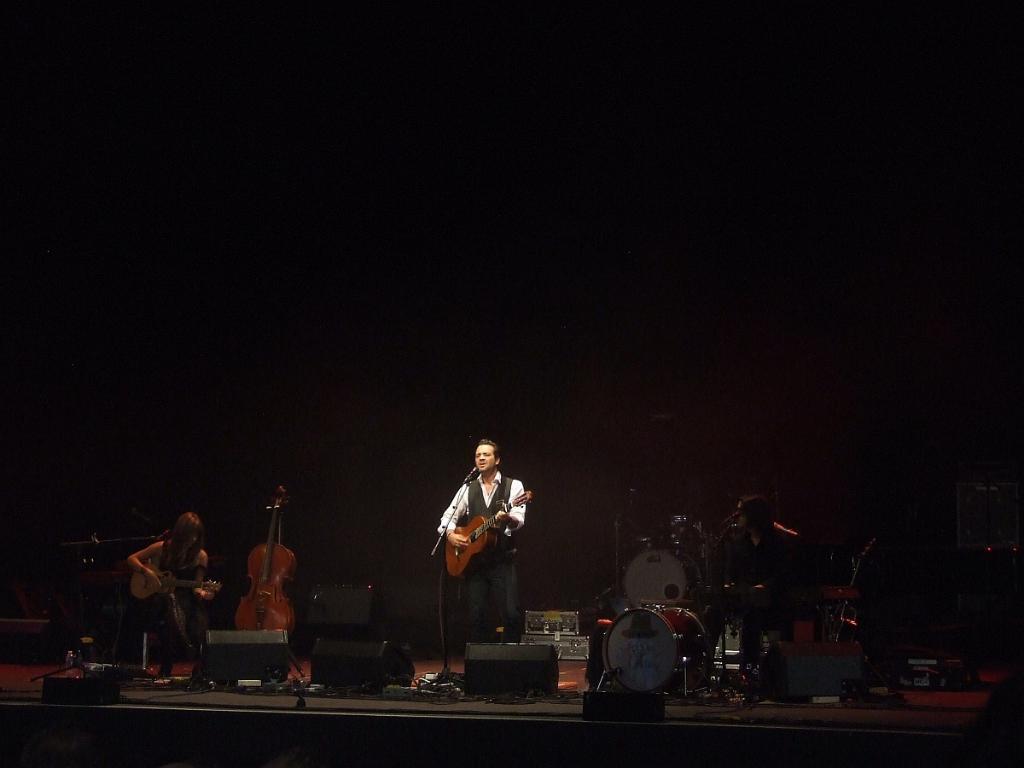Please provide a concise description of this image. This is a picture of a concert. In the center a man is standing, playing guitar and singing. On the right there is a man playing drums. On the left there is a woman seated and playing guitar. There are many musical instruments on the stage. Background is dark. 